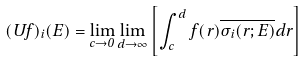Convert formula to latex. <formula><loc_0><loc_0><loc_500><loc_500>( U f ) _ { i } ( E ) = \lim _ { c \to 0 } \lim _ { d \to \infty } \left [ \int _ { c } ^ { d } f ( r ) \overline { \sigma _ { i } ( r ; E ) } d r \right ]</formula> 